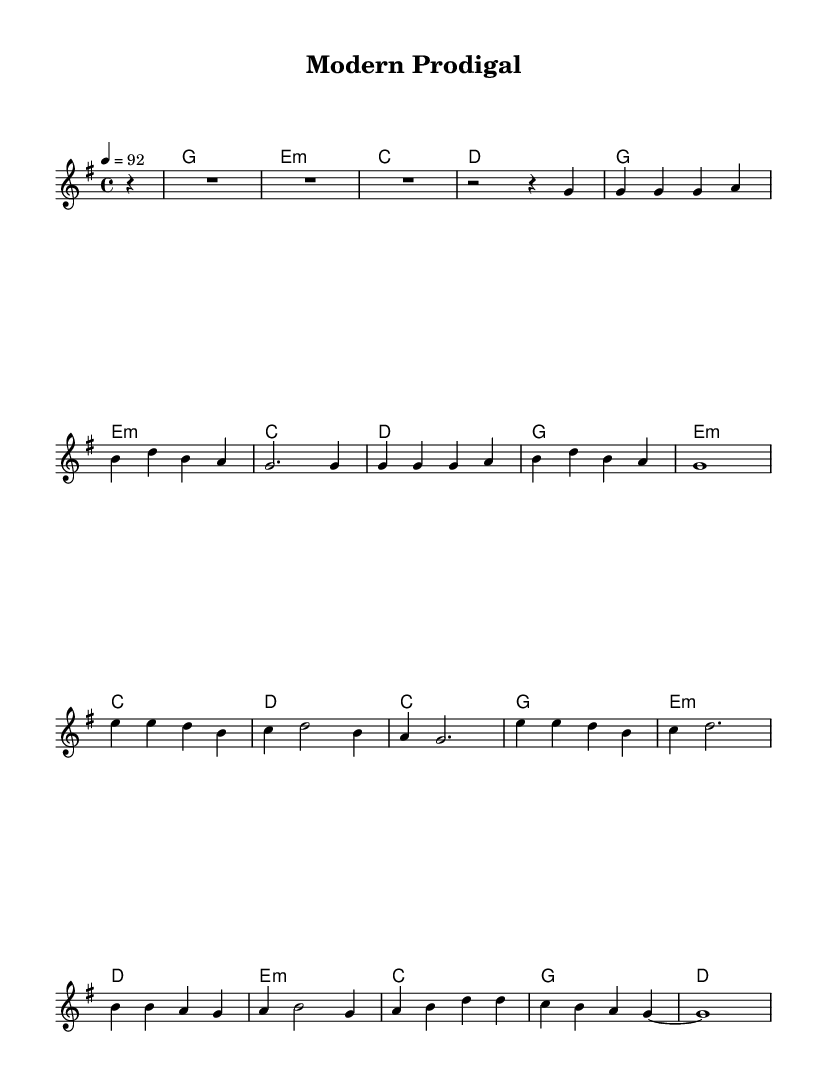What is the key signature of this music? The key signature is G major, which has one sharp (F#) indicated at the beginning of the staff.
Answer: G major What is the time signature of this music? The time signature is 4/4, meaning there are four beats in a measure and the quarter note gets one beat.
Answer: 4/4 What is the tempo marking of this piece? The tempo marking indicates a speed of 92 beats per minute, suggesting a moderate pace for the music.
Answer: 92 How many measures are in the melody section? By counting the entries between the vertical lines, there are a total of 17 measures in the melody section.
Answer: 17 What chord follows the G major chord in the harmonies? The chord that follows the G major chord is E minor, which is indicated as ‘e1:m’ in the chord progression.
Answer: E minor What is the main theme represented in this piece? The main theme revolves around the parable of the Prodigal Son, as indicated by the title "Modern Prodigal."
Answer: Prodigal Son How does this music style reflect modern Christian themes? The integration of contemporary hip hop with biblical narratives creates relatable messages for today's audience, bridging faith with modern experiences.
Answer: Relatable messages 